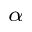<formula> <loc_0><loc_0><loc_500><loc_500>_ { \alpha }</formula> 